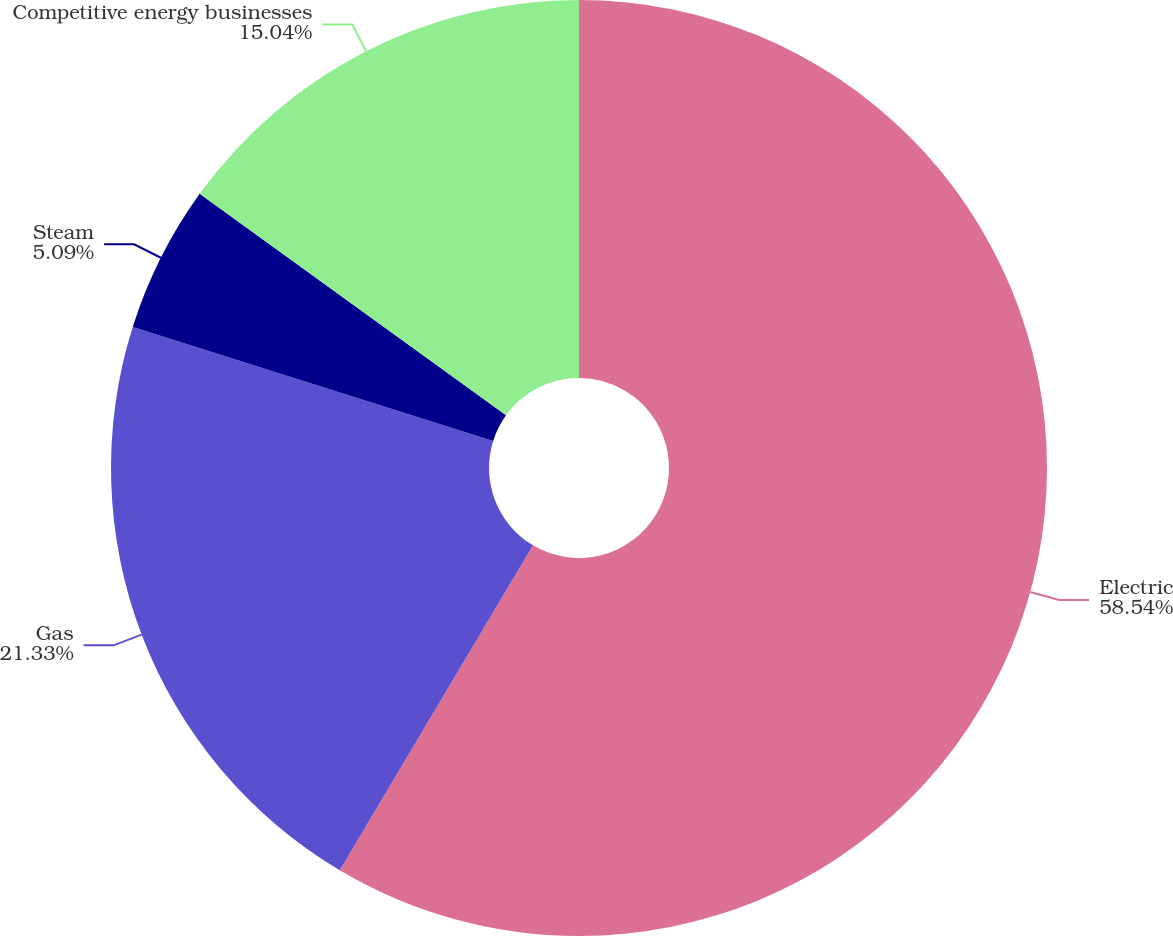Convert chart. <chart><loc_0><loc_0><loc_500><loc_500><pie_chart><fcel>Electric<fcel>Gas<fcel>Steam<fcel>Competitive energy businesses<nl><fcel>58.54%<fcel>21.33%<fcel>5.09%<fcel>15.04%<nl></chart> 